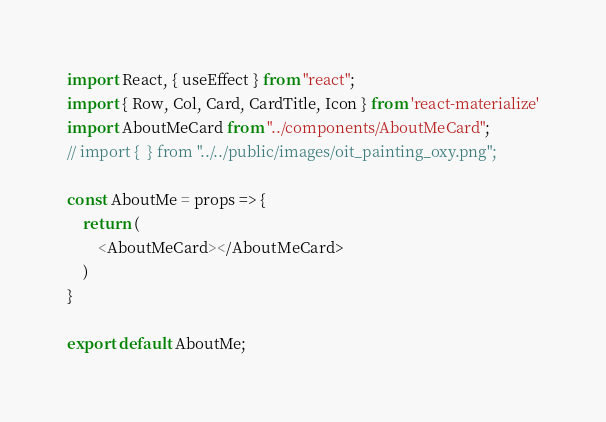<code> <loc_0><loc_0><loc_500><loc_500><_JavaScript_>import React, { useEffect } from "react";
import { Row, Col, Card, CardTitle, Icon } from 'react-materialize'
import AboutMeCard from "../components/AboutMeCard";
// import {  } from "../../public/images/oit_painting_oxy.png";

const AboutMe = props => {
    return (
        <AboutMeCard></AboutMeCard>
    )
}

export default AboutMe;</code> 